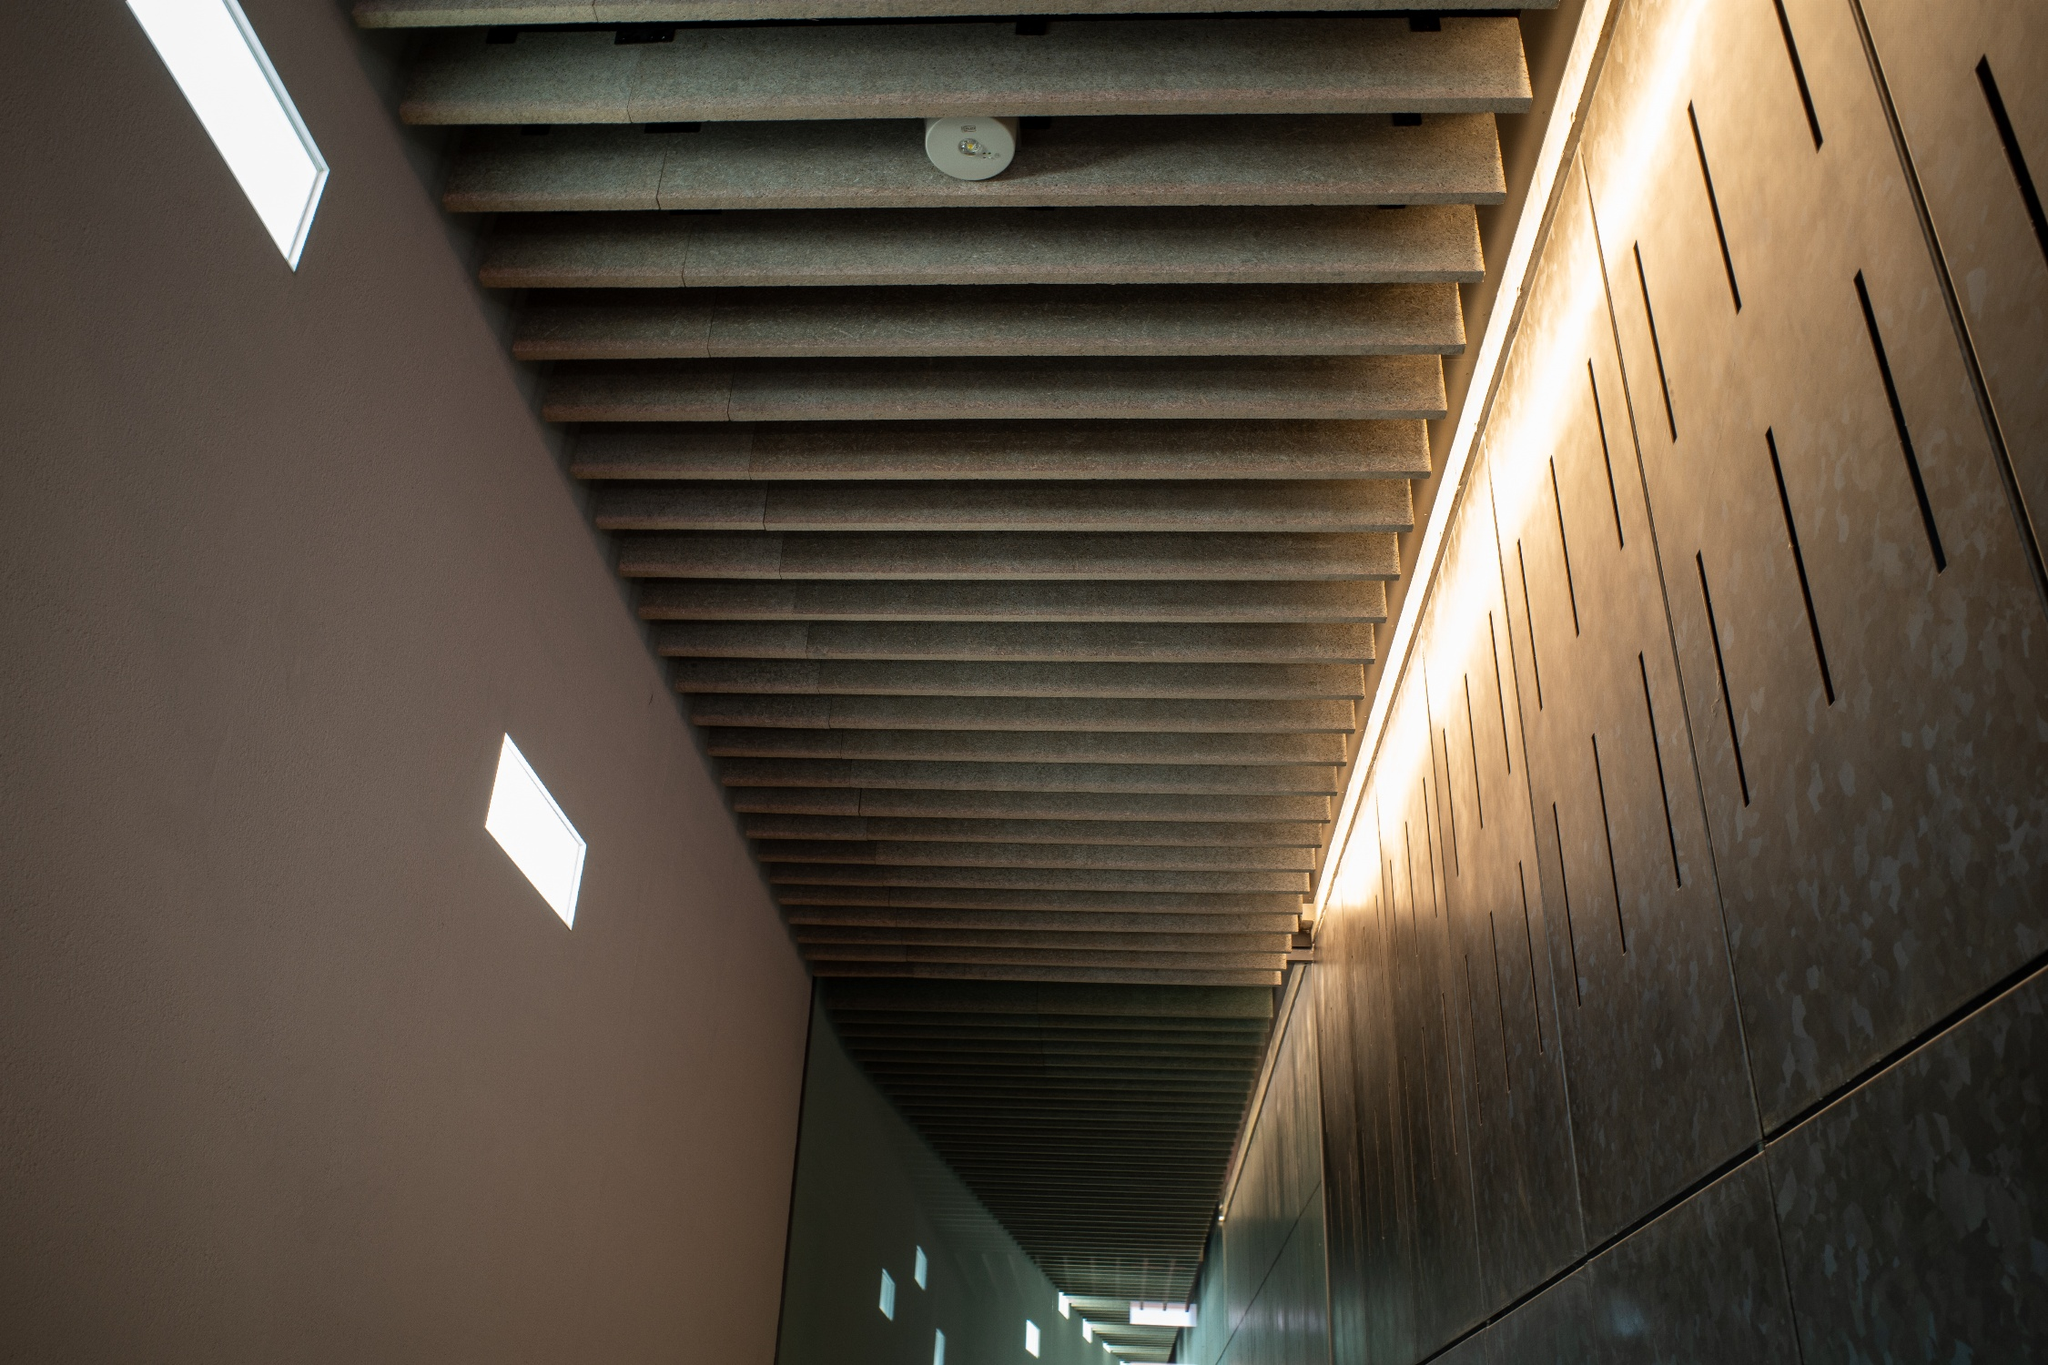Describe a realistic scenario of the image in a hotel setting (short response). This hallway is a tranquil pathway in a high-end hotel, guiding guests from their rooms to the wellness spa. The calming, minimalist design helps to set a relaxing tone for visitors, with the soft lighting and polished stone floors enhancing the serene atmosphere. 